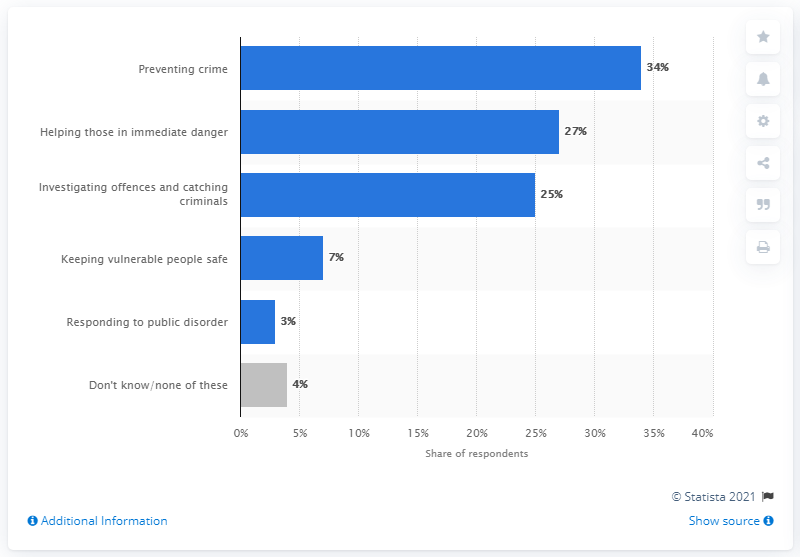Draw attention to some important aspects in this diagram. According to a recent survey in Britain, a significant majority of people stated that protecting vulnerable individuals was their top priority. In 2014, the most common answer given by individuals in Great Britain to the police inquiry was to prevent crime. 